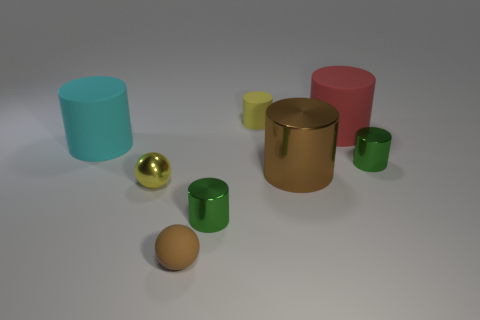What material is the small thing that is behind the tiny yellow shiny ball and in front of the big red cylinder?
Give a very brief answer. Metal. There is a tiny shiny object that is on the left side of the small brown sphere; is there a small green cylinder that is in front of it?
Provide a succinct answer. Yes. Is the material of the big cyan object the same as the small yellow sphere?
Ensure brevity in your answer.  No. What is the shape of the small thing that is both to the left of the big brown object and behind the yellow shiny ball?
Your response must be concise. Cylinder. What is the size of the rubber thing that is in front of the small metallic object on the right side of the large brown shiny cylinder?
Offer a terse response. Small. What number of shiny things have the same shape as the big cyan rubber thing?
Your answer should be very brief. 3. Is the big metallic thing the same color as the small rubber cylinder?
Offer a terse response. No. Are there any other things that are the same shape as the tiny yellow shiny object?
Ensure brevity in your answer.  Yes. Is there a small shiny cylinder of the same color as the tiny matte cylinder?
Provide a short and direct response. No. Are the cylinder that is in front of the brown metal thing and the tiny yellow object behind the cyan thing made of the same material?
Provide a succinct answer. No. 